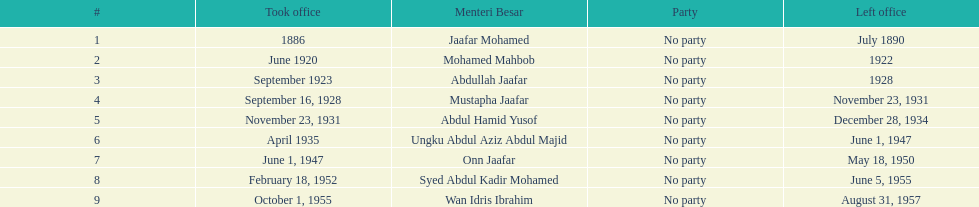Who was in office previous to abdullah jaafar? Mohamed Mahbob. 